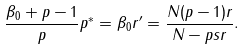Convert formula to latex. <formula><loc_0><loc_0><loc_500><loc_500>\frac { \beta _ { 0 } + p - 1 } { p } p ^ { * } = \beta _ { 0 } r ^ { \prime } = \frac { N ( p - 1 ) r } { N - p s r } .</formula> 